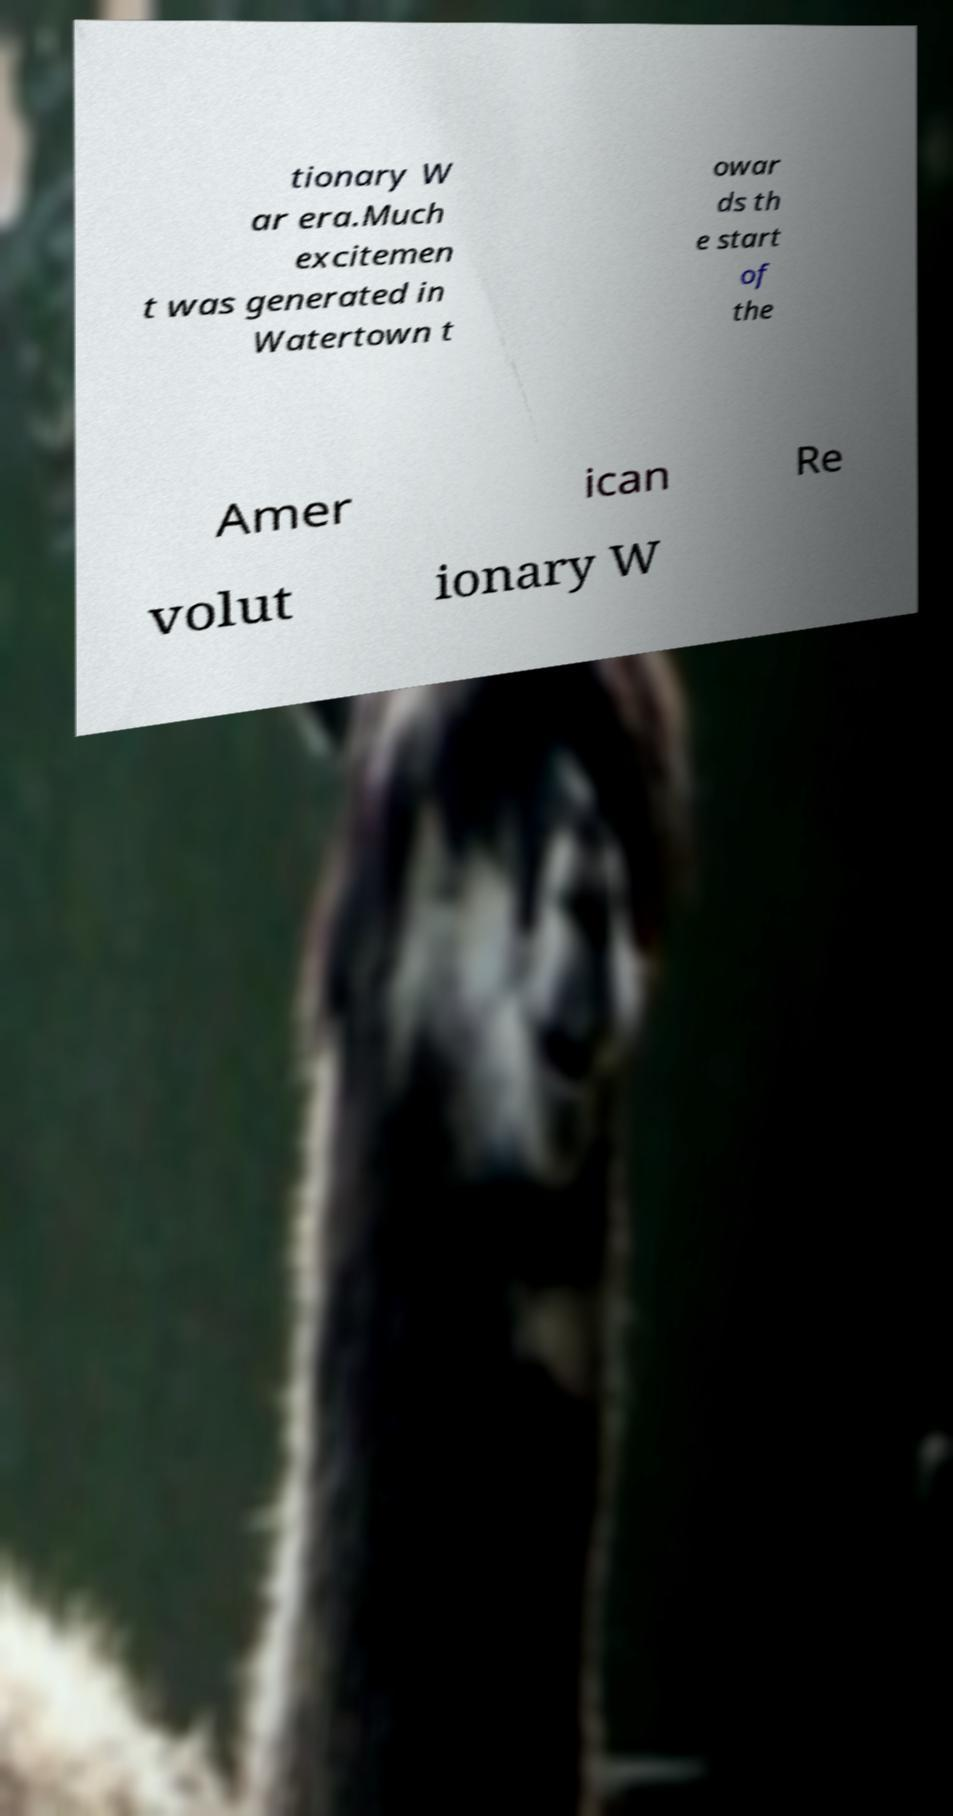What messages or text are displayed in this image? I need them in a readable, typed format. tionary W ar era.Much excitemen t was generated in Watertown t owar ds th e start of the Amer ican Re volut ionary W 